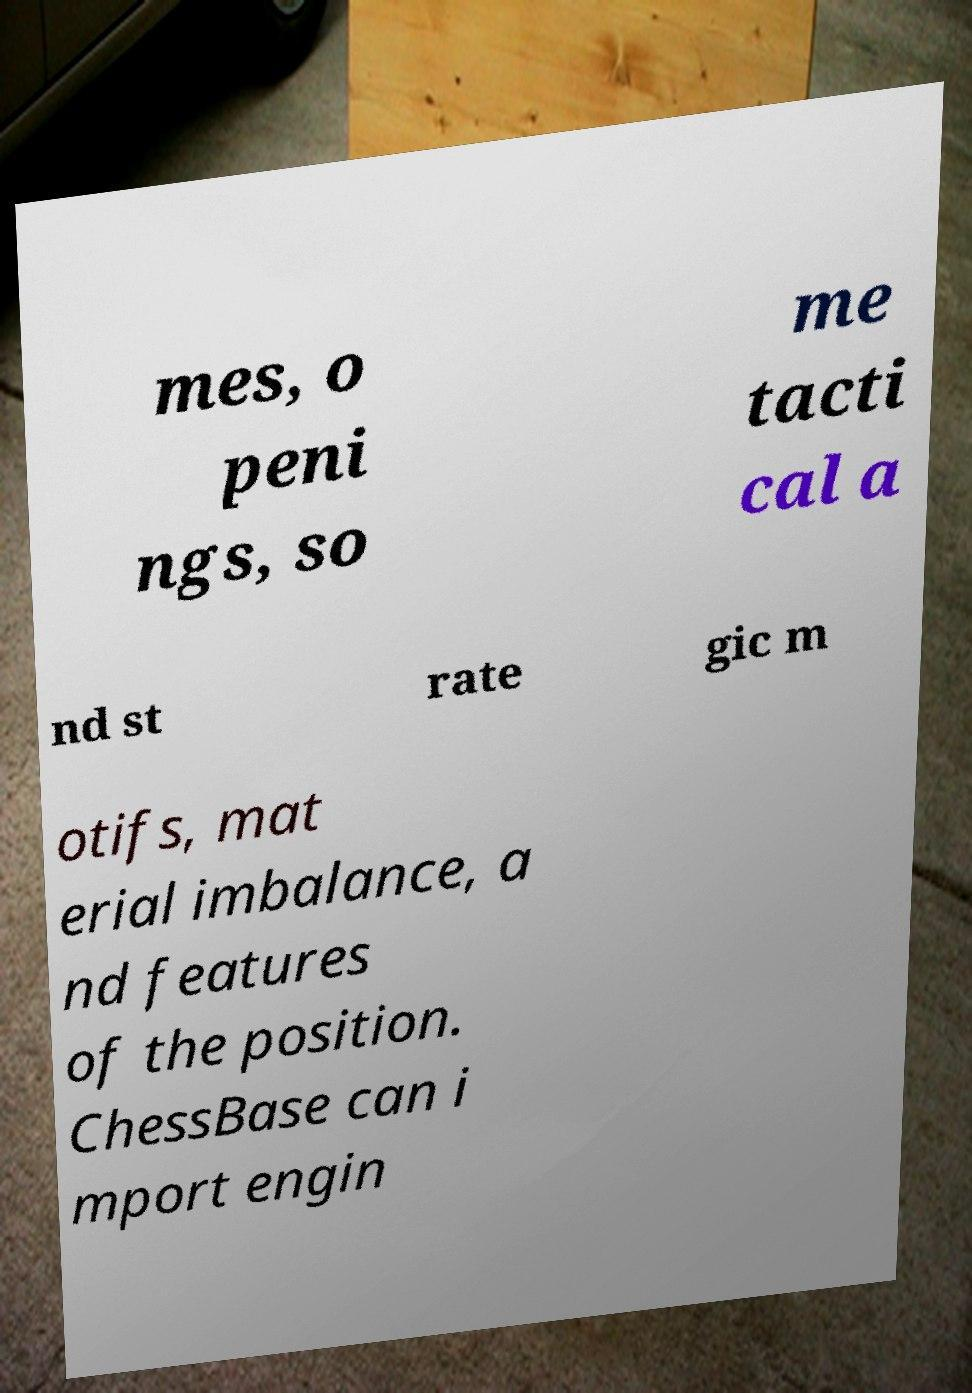I need the written content from this picture converted into text. Can you do that? mes, o peni ngs, so me tacti cal a nd st rate gic m otifs, mat erial imbalance, a nd features of the position. ChessBase can i mport engin 